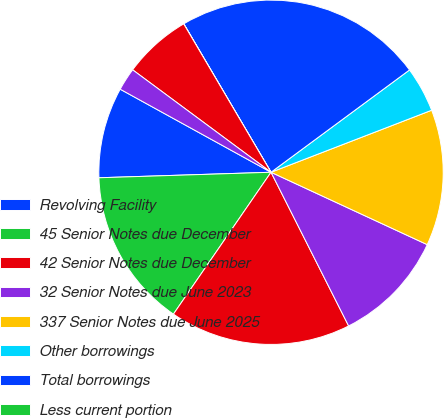Convert chart. <chart><loc_0><loc_0><loc_500><loc_500><pie_chart><fcel>Revolving Facility<fcel>45 Senior Notes due December<fcel>42 Senior Notes due December<fcel>32 Senior Notes due June 2023<fcel>337 Senior Notes due June 2025<fcel>Other borrowings<fcel>Total borrowings<fcel>Less current portion<fcel>Less deferred debt issuance<fcel>Less unaccreted debt discount<nl><fcel>8.52%<fcel>14.9%<fcel>17.03%<fcel>10.65%<fcel>12.77%<fcel>4.26%<fcel>23.33%<fcel>0.01%<fcel>6.39%<fcel>2.13%<nl></chart> 